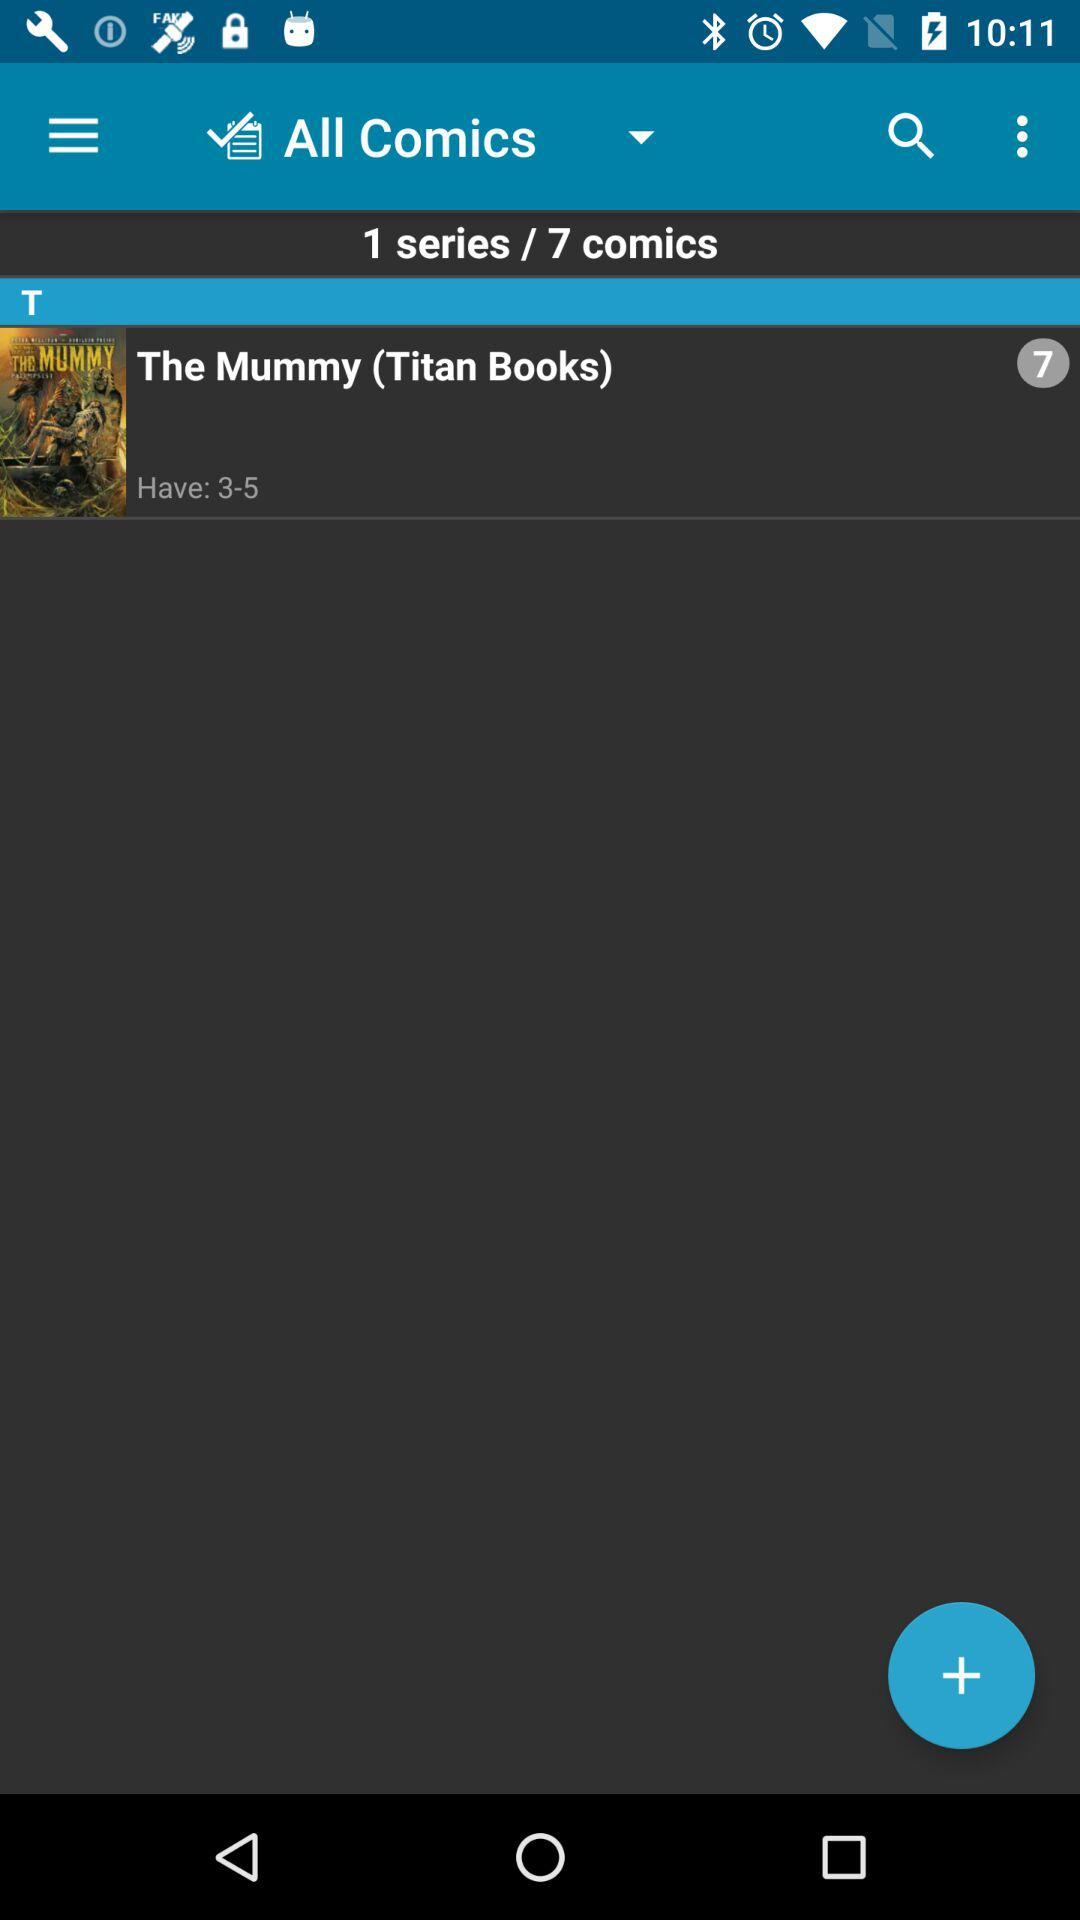How many comics are there? There are 7 comics. 